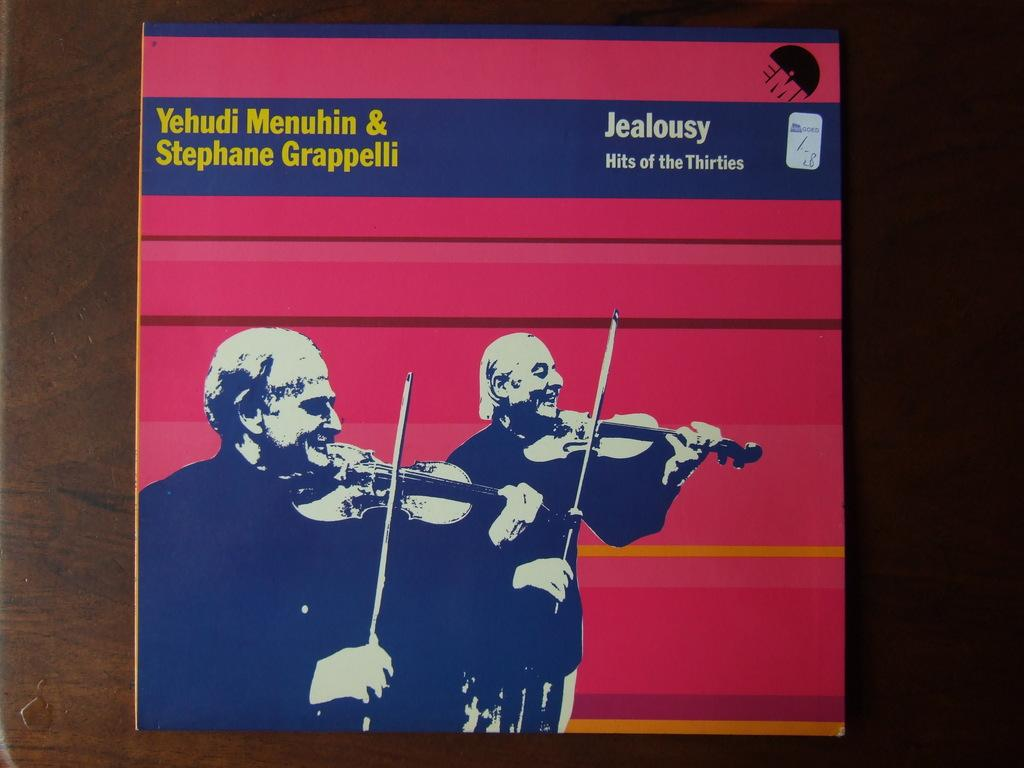<image>
Relay a brief, clear account of the picture shown. A record album featuring two violinists is titled Jealousy Hits of the Thirties. 